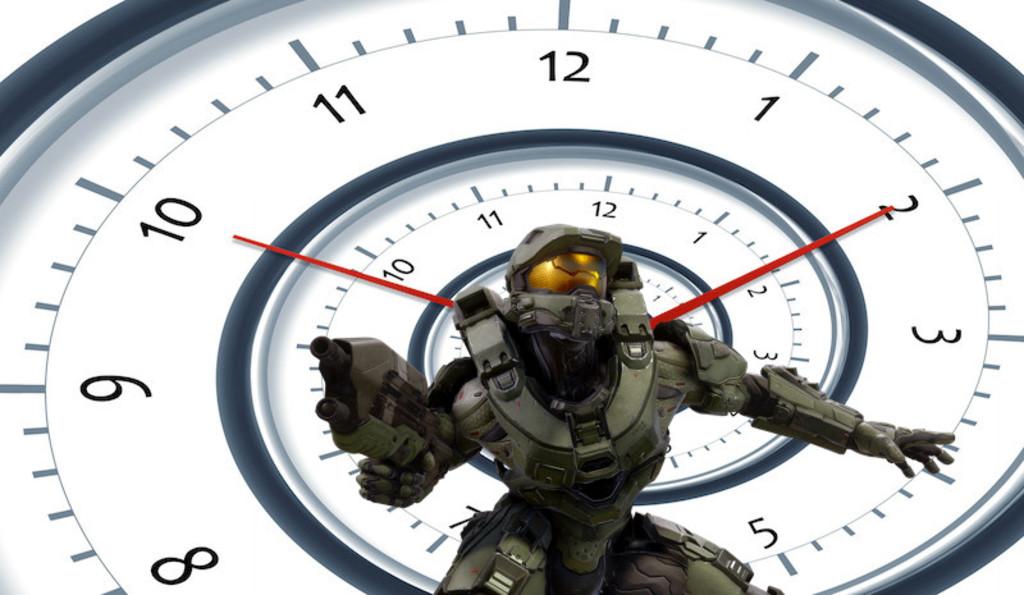What is the time on the clock?
Offer a very short reply. 10:10. What number is top center?
Offer a terse response. 12. 